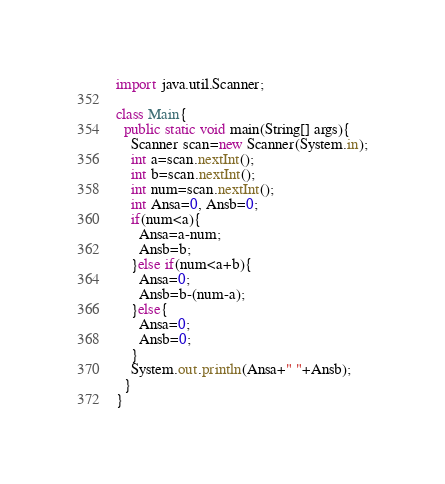<code> <loc_0><loc_0><loc_500><loc_500><_Java_>import java.util.Scanner;

class Main{
  public static void main(String[] args){
    Scanner scan=new Scanner(System.in);
    int a=scan.nextInt();
    int b=scan.nextInt();
    int num=scan.nextInt();
    int Ansa=0, Ansb=0;
    if(num<a){
      Ansa=a-num;
      Ansb=b;
    }else if(num<a+b){
      Ansa=0;
      Ansb=b-(num-a);
    }else{
      Ansa=0;
      Ansb=0;
    }
    System.out.println(Ansa+" "+Ansb);
  }
}</code> 